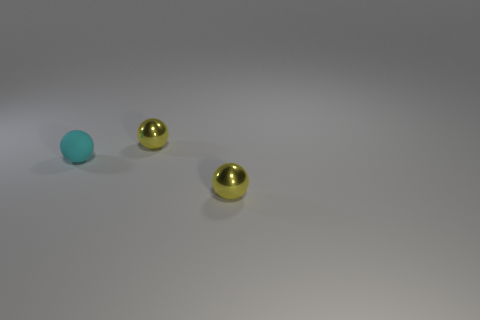Add 3 tiny cyan rubber things. How many objects exist? 6 Subtract all big blue matte things. Subtract all tiny rubber objects. How many objects are left? 2 Add 3 small matte balls. How many small matte balls are left? 4 Add 3 small shiny objects. How many small shiny objects exist? 5 Subtract 0 brown spheres. How many objects are left? 3 